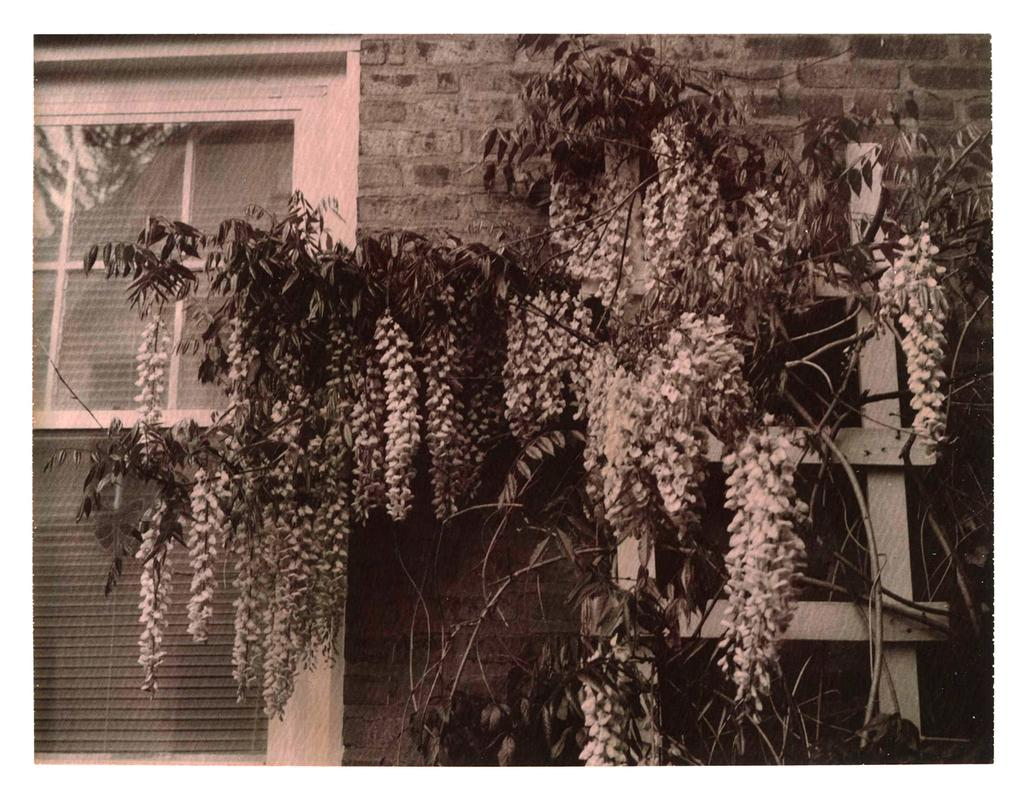What is the color scheme of the image? The image is black and white. What type of natural elements can be seen in the image? There are trees in the image. What type of structure is present in the image? There is a building in the image. What material is the building is made of? The building is made of bricks. What feature of the building can be seen in the image? There is a white window in the building. What type of wool is being spun in the image? There is no wool or spinning activity present in the image. 